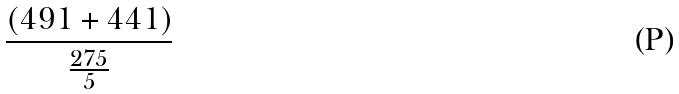Convert formula to latex. <formula><loc_0><loc_0><loc_500><loc_500>\frac { ( 4 9 1 + 4 4 1 ) } { \frac { 2 7 5 } { 5 } }</formula> 